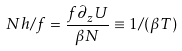<formula> <loc_0><loc_0><loc_500><loc_500>N h / f = \frac { f \partial _ { z } U } { \beta N } \equiv 1 / ( \beta T )</formula> 